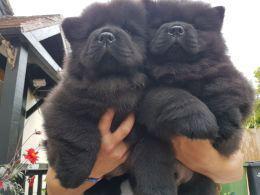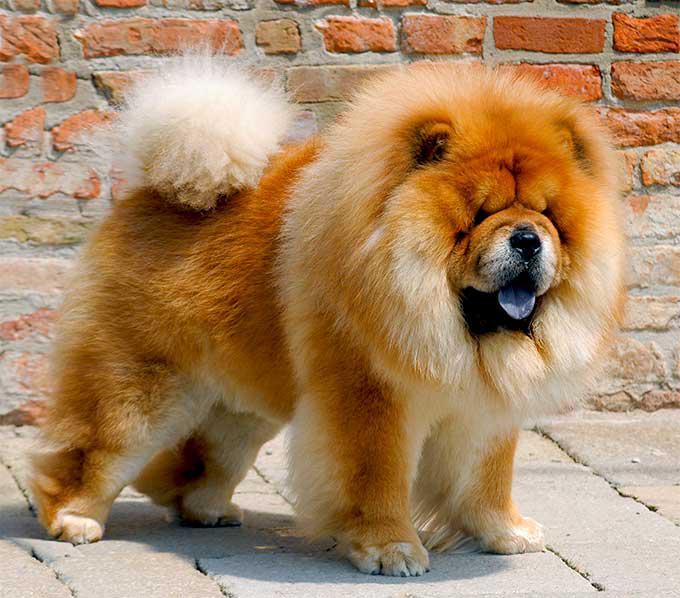The first image is the image on the left, the second image is the image on the right. Considering the images on both sides, is "There are two dogs" valid? Answer yes or no. No. The first image is the image on the left, the second image is the image on the right. For the images shown, is this caption "Two young chows are side-by-side in one of the images." true? Answer yes or no. Yes. 